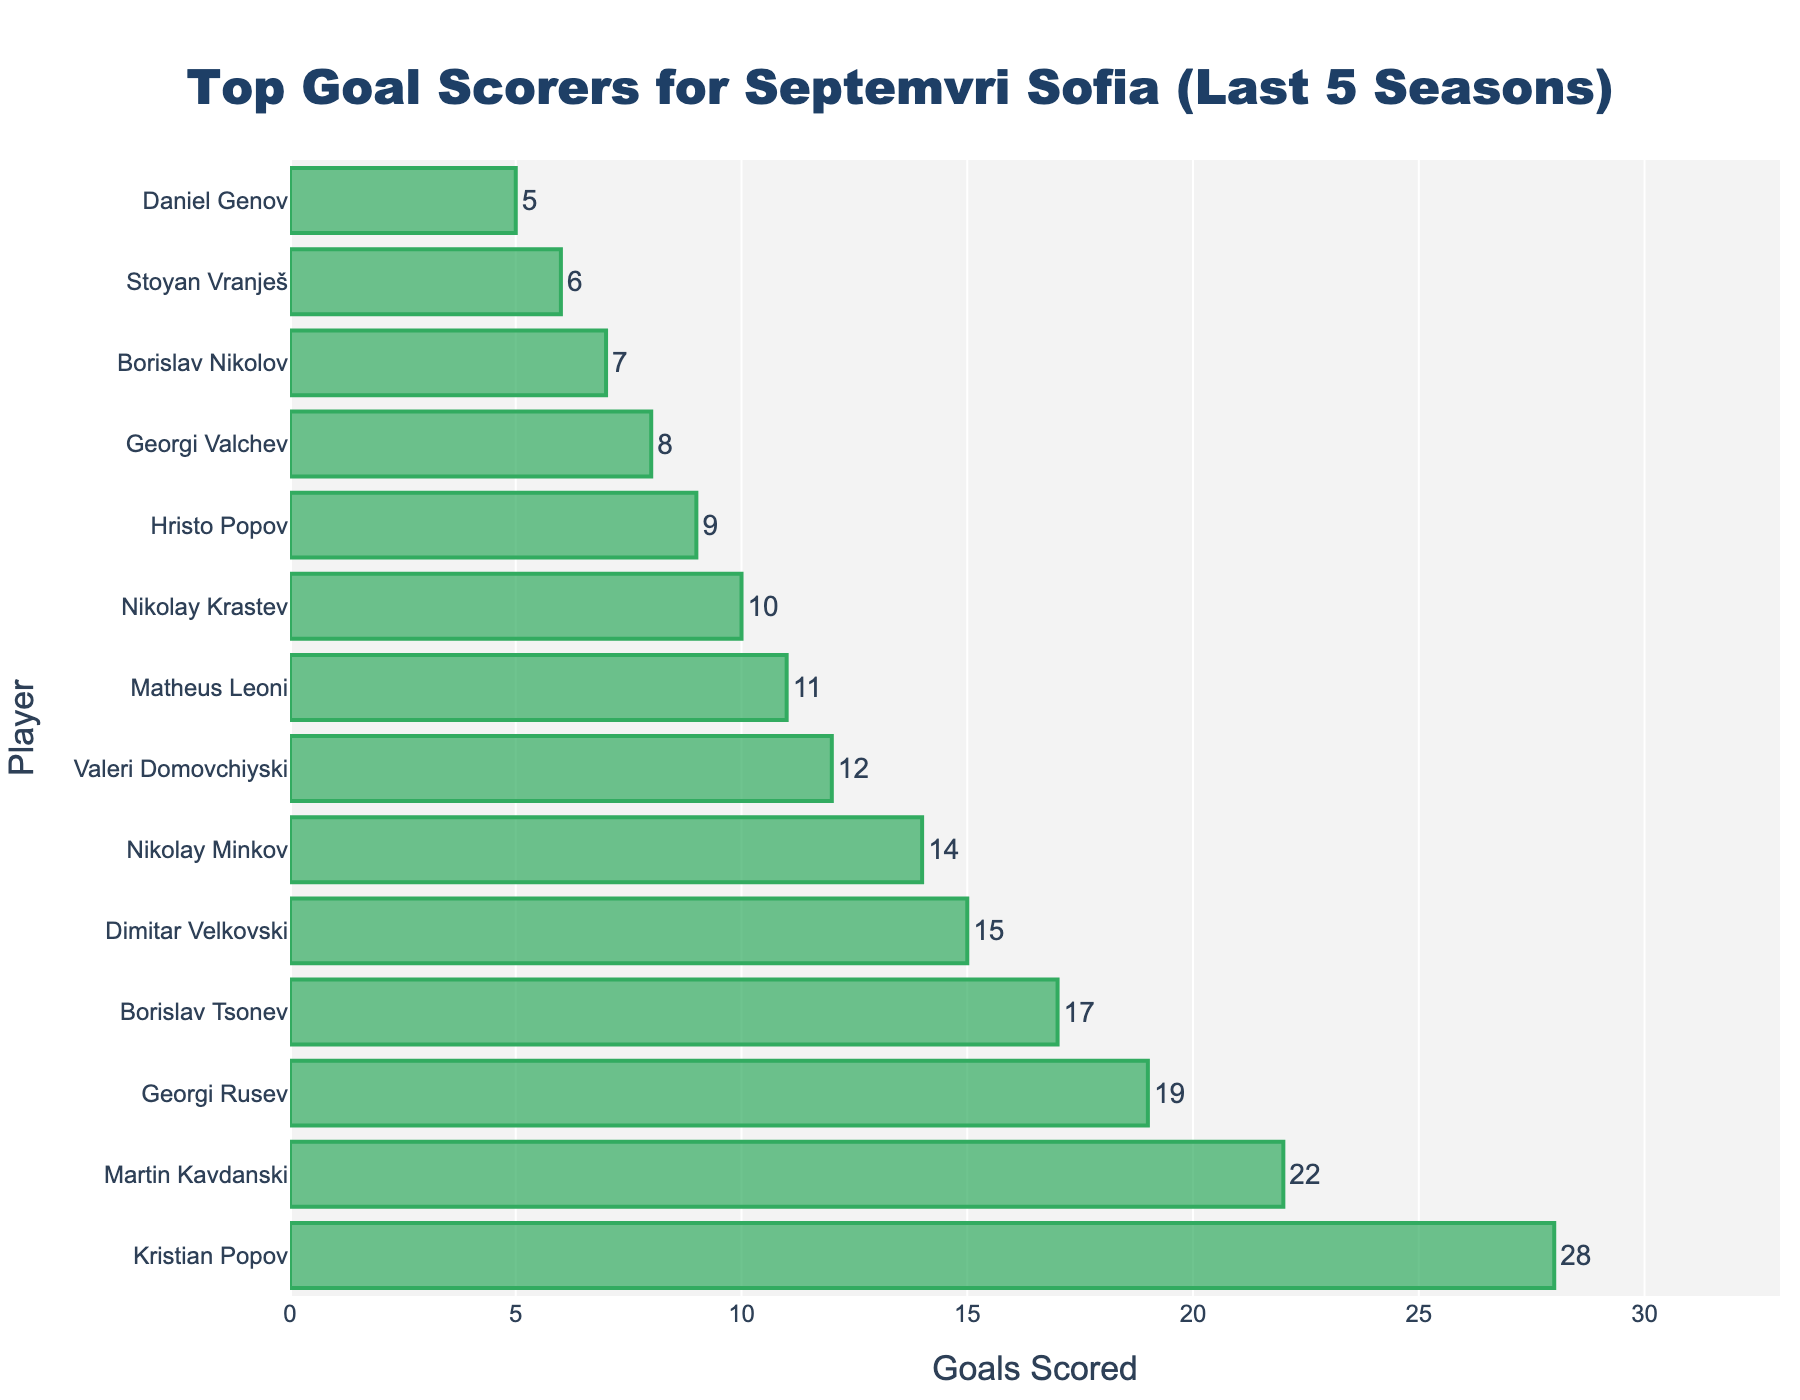Which player scored the most goals for Septemvri Sofia in the last 5 seasons? Look for the player with the longest bar in the chart. Kristian Popov has the longest bar indicating he scored the most goals.
Answer: Kristian Popov How many goals did Martin Kavdanski score? Find Martin Kavdanski on the y-axis and read his corresponding bar length on the x-axis, which shows he scored 22 goals.
Answer: 22 What is the total number of goals scored by Georgi Rusev and Borislav Tsonev combined? Find the goal numbers for both players and add them together. Georgi Rusev scored 19 and Borislav Tsonev scored 17, so 19 + 17 = 36 goals.
Answer: 36 Which player scored more goals: Dimitar Velkovski or Nikolay Minkov? Compare the bars corresponding to both players. Dimitar Velkovski's bar shows he scored 15 goals, while Nikolay Minkov's bar indicates he scored 14 goals. Therefore, Dimitar Velkovski scored more.
Answer: Dimitar Velkovski How many players scored 10 or more goals? Count the number of bars with values 10 or higher. The players are Kristian Popov, Martin Kavdanski, Georgi Rusev, Borislav Tsonev, Dimitar Velkovski, Nikolay Minkov, Valeri Domovchiyski, Matheus Leoni, and Nikolay Krastev. Hence, 9 players.
Answer: 9 What is the difference in goals scored between the highest and the lowest scorers on the chart? Identify the highest scorer (Kristian Popov, 28 goals) and the lowest scorer (Daniel Genov, 5 goals) and subtract the two. The difference is 28 - 5 = 23 goals.
Answer: 23 Is there any player who scored exactly 7 goals? Search for the bar that corresponds to 7 goals. Borislav Nikolov's bar shows exactly 7 goals.
Answer: Yes Who scored one less goal than Hristo Popov? Hristo Popov has 9 goals. Look for the bar representing 8 goals, which is Georgi Valchev.
Answer: Georgi Valchev Which players have scored more than 15 goals? Identify players with bars extending beyond the 15-goal mark. They are Kristian Popov (28), Martin Kavdanski (22), Georgi Rusev (19), and Borislav Tsonev (17).
Answer: Kristian Popov, Martin Kavdanski, Georgi Rusev, Borislav Tsonev 